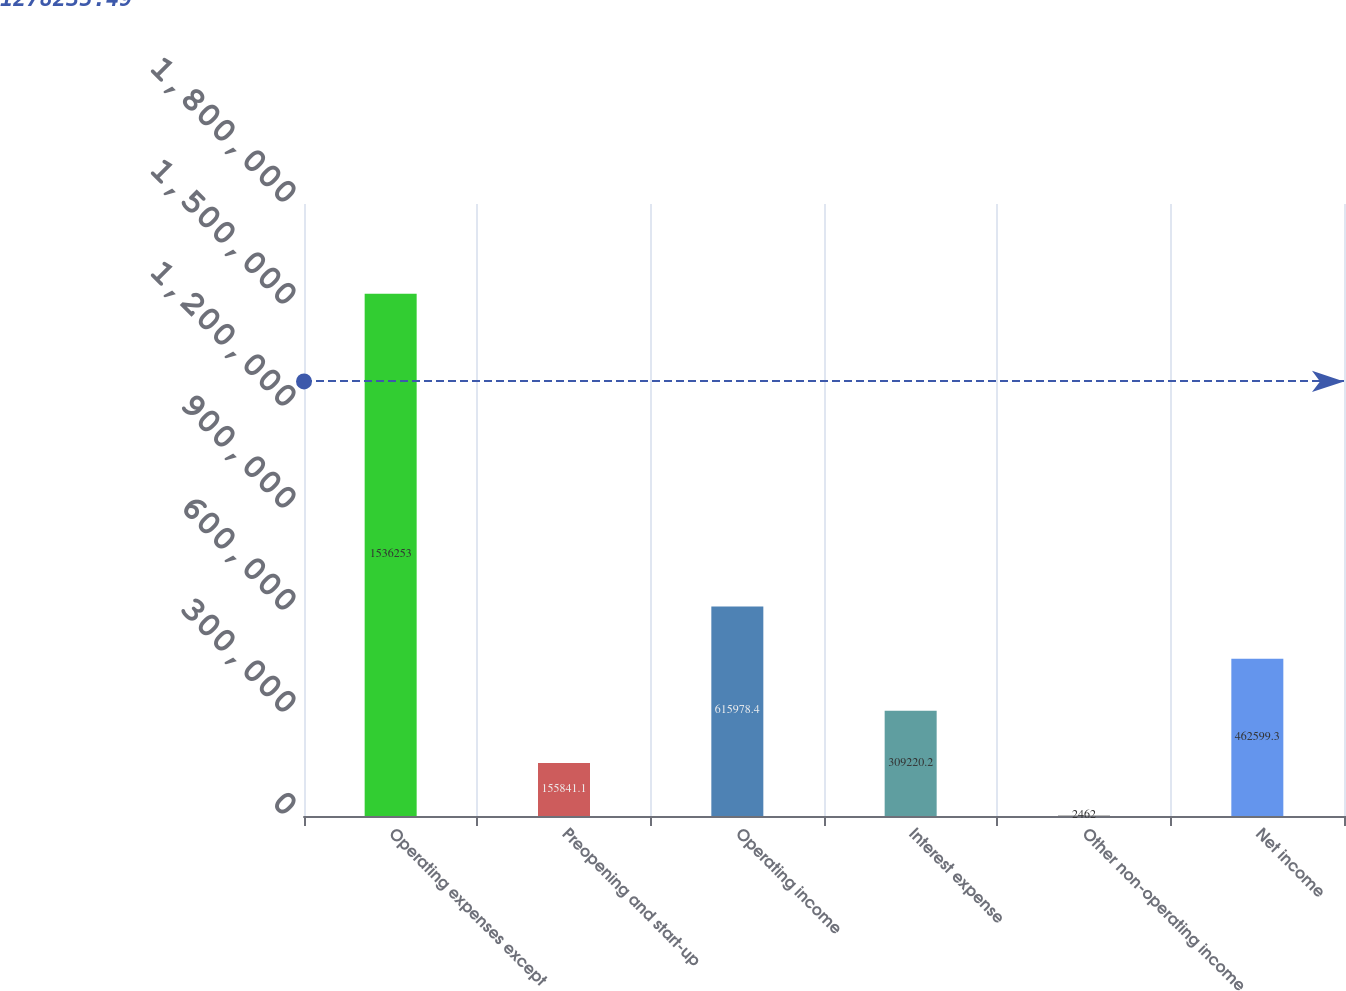<chart> <loc_0><loc_0><loc_500><loc_500><bar_chart><fcel>Operating expenses except<fcel>Preopening and start-up<fcel>Operating income<fcel>Interest expense<fcel>Other non-operating income<fcel>Net income<nl><fcel>1.53625e+06<fcel>155841<fcel>615978<fcel>309220<fcel>2462<fcel>462599<nl></chart> 